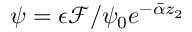Convert formula to latex. <formula><loc_0><loc_0><loc_500><loc_500>\psi = \epsilon \mathcal { F } / \psi _ { 0 } e ^ { - \bar { \alpha } z _ { 2 } }</formula> 